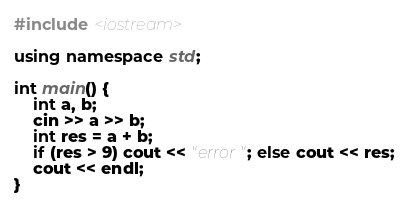Convert code to text. <code><loc_0><loc_0><loc_500><loc_500><_C++_>#include <iostream>

using namespace std;

int main() {
    int a, b;
    cin >> a >> b;
    int res = a + b;
    if (res > 9) cout << "error"; else cout << res;
    cout << endl;
}
</code> 